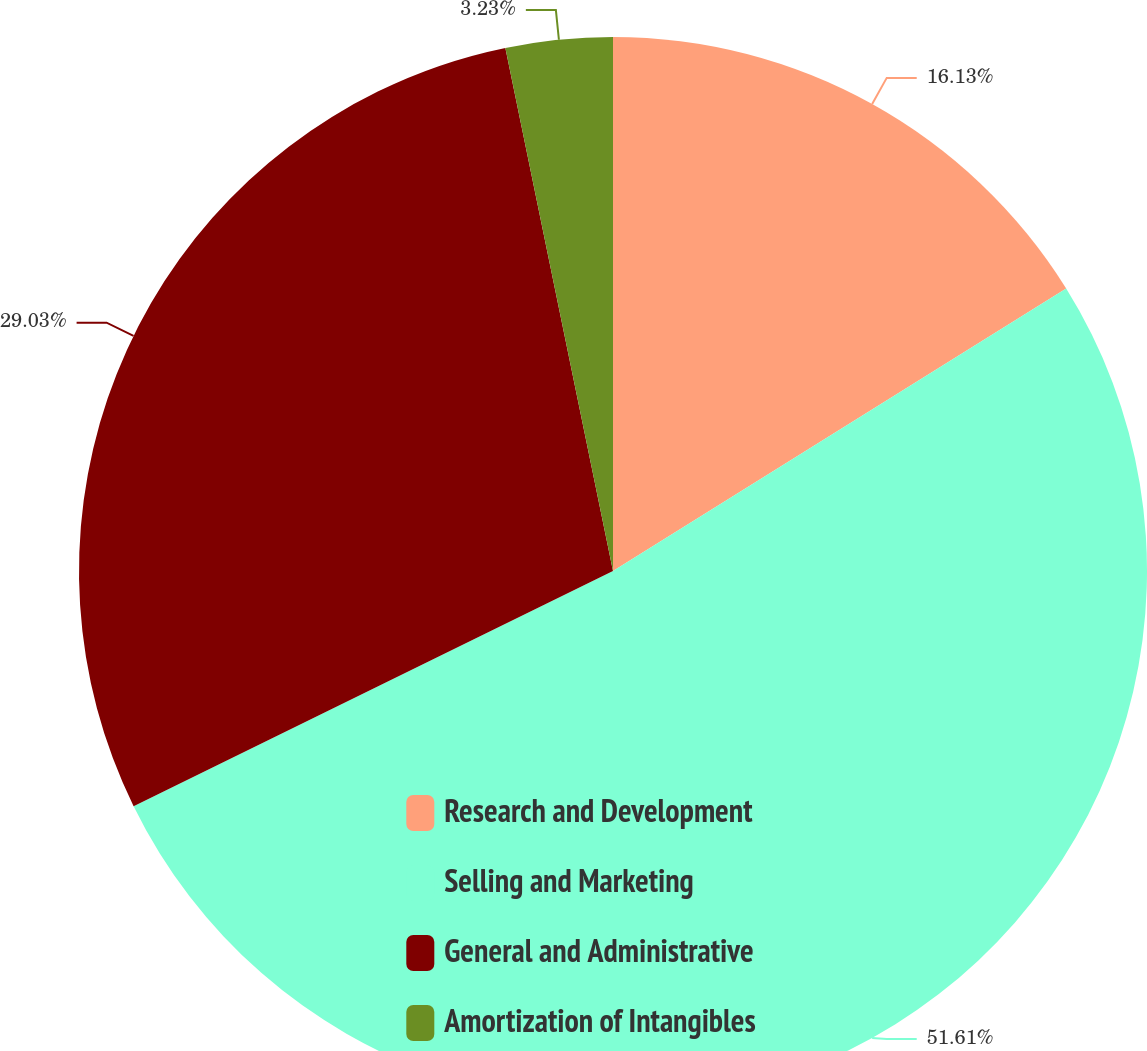Convert chart. <chart><loc_0><loc_0><loc_500><loc_500><pie_chart><fcel>Research and Development<fcel>Selling and Marketing<fcel>General and Administrative<fcel>Amortization of Intangibles<nl><fcel>16.13%<fcel>51.61%<fcel>29.03%<fcel>3.23%<nl></chart> 